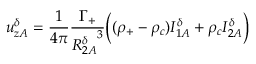Convert formula to latex. <formula><loc_0><loc_0><loc_500><loc_500>u _ { z A } ^ { \delta } = \frac { 1 } { 4 \pi } \frac { \Gamma _ { + } } { { R _ { 2 A } ^ { \delta } } ^ { 3 } } \left ( ( \rho _ { + } - \rho _ { c } ) I _ { 1 A } ^ { \delta } + \rho _ { c } I _ { 2 A } ^ { \delta } \right )</formula> 